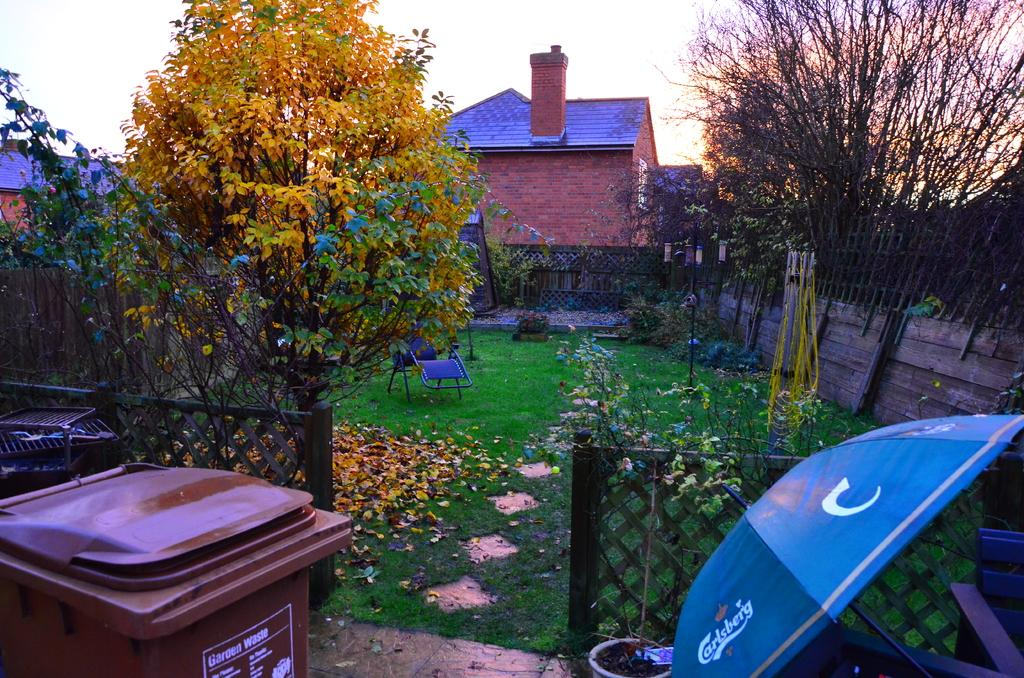What type of barrier can be seen in the image? There is a fence in the image. What object is present for waste disposal? There is a bin in the image. image. What is used for protection from the sun or rain in the image? There is an umbrella in the image. What type of vegetation is present in the image? There is grass in the image. What type of tall plants can be seen in the image? There are trees in the image. What type of structures are visible in the background of the image? There are houses in the background of the image. What type of vertical structure is present in the image? There is a light pole in the image. How many rabbits are hopping around the light pole in the image? There are no rabbits present in the image. What channel is the fence tuned to in the image? The fence is not a television or device that can be tuned to a channel; it is a barrier in the image. 